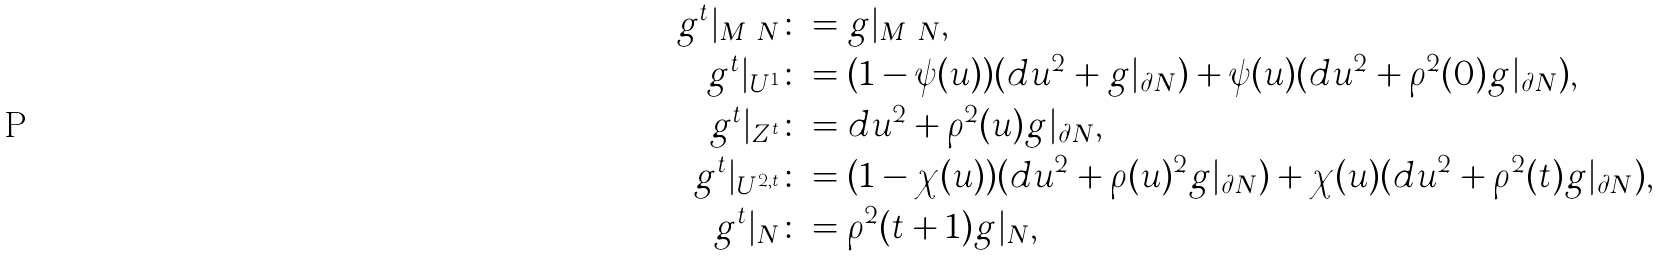<formula> <loc_0><loc_0><loc_500><loc_500>g ^ { t } | _ { M \ N } \colon & = g | _ { M \ N } , \\ g ^ { t } | _ { U ^ { 1 } } \colon & = ( 1 - \psi ( u ) ) ( d u ^ { 2 } + g | _ { \partial N } ) + \psi ( u ) ( d u ^ { 2 } + \rho ^ { 2 } ( 0 ) g | _ { \partial N } ) , \\ g ^ { t } | _ { Z ^ { t } } \colon & = d u ^ { 2 } + \rho ^ { 2 } ( u ) g | _ { \partial N } , \\ g ^ { t } | _ { U ^ { 2 , t } } \colon & = ( 1 - \chi ( u ) ) ( d u ^ { 2 } + \rho ( u ) ^ { 2 } g | _ { \partial N } ) + \chi ( u ) ( d u ^ { 2 } + \rho ^ { 2 } ( t ) g | _ { \partial N } ) , \\ g ^ { t } | _ { N } \colon & = \rho ^ { 2 } ( t + 1 ) g | _ { N } ,</formula> 